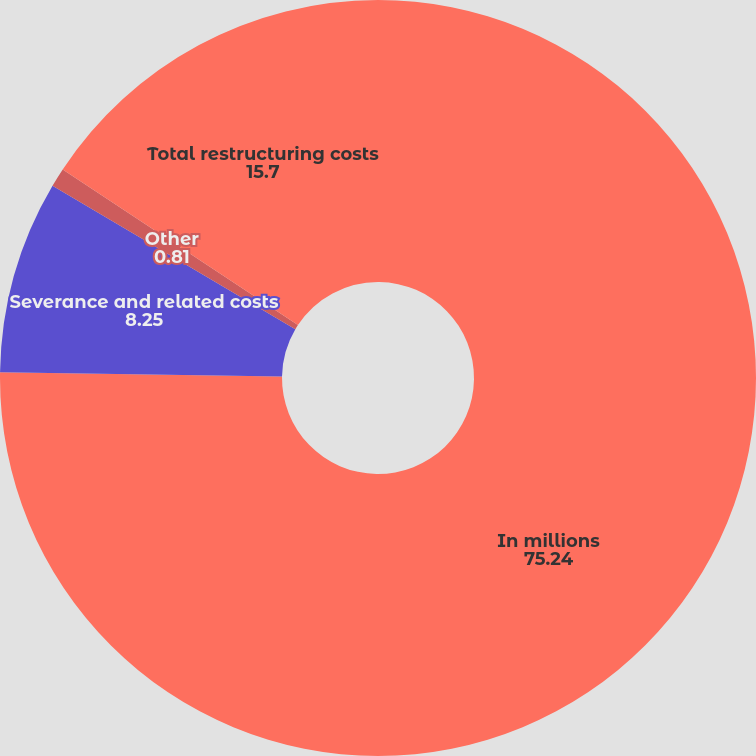Convert chart. <chart><loc_0><loc_0><loc_500><loc_500><pie_chart><fcel>In millions<fcel>Severance and related costs<fcel>Other<fcel>Total restructuring costs<nl><fcel>75.24%<fcel>8.25%<fcel>0.81%<fcel>15.7%<nl></chart> 